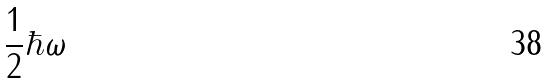Convert formula to latex. <formula><loc_0><loc_0><loc_500><loc_500>\frac { 1 } { 2 } \hbar { \omega }</formula> 